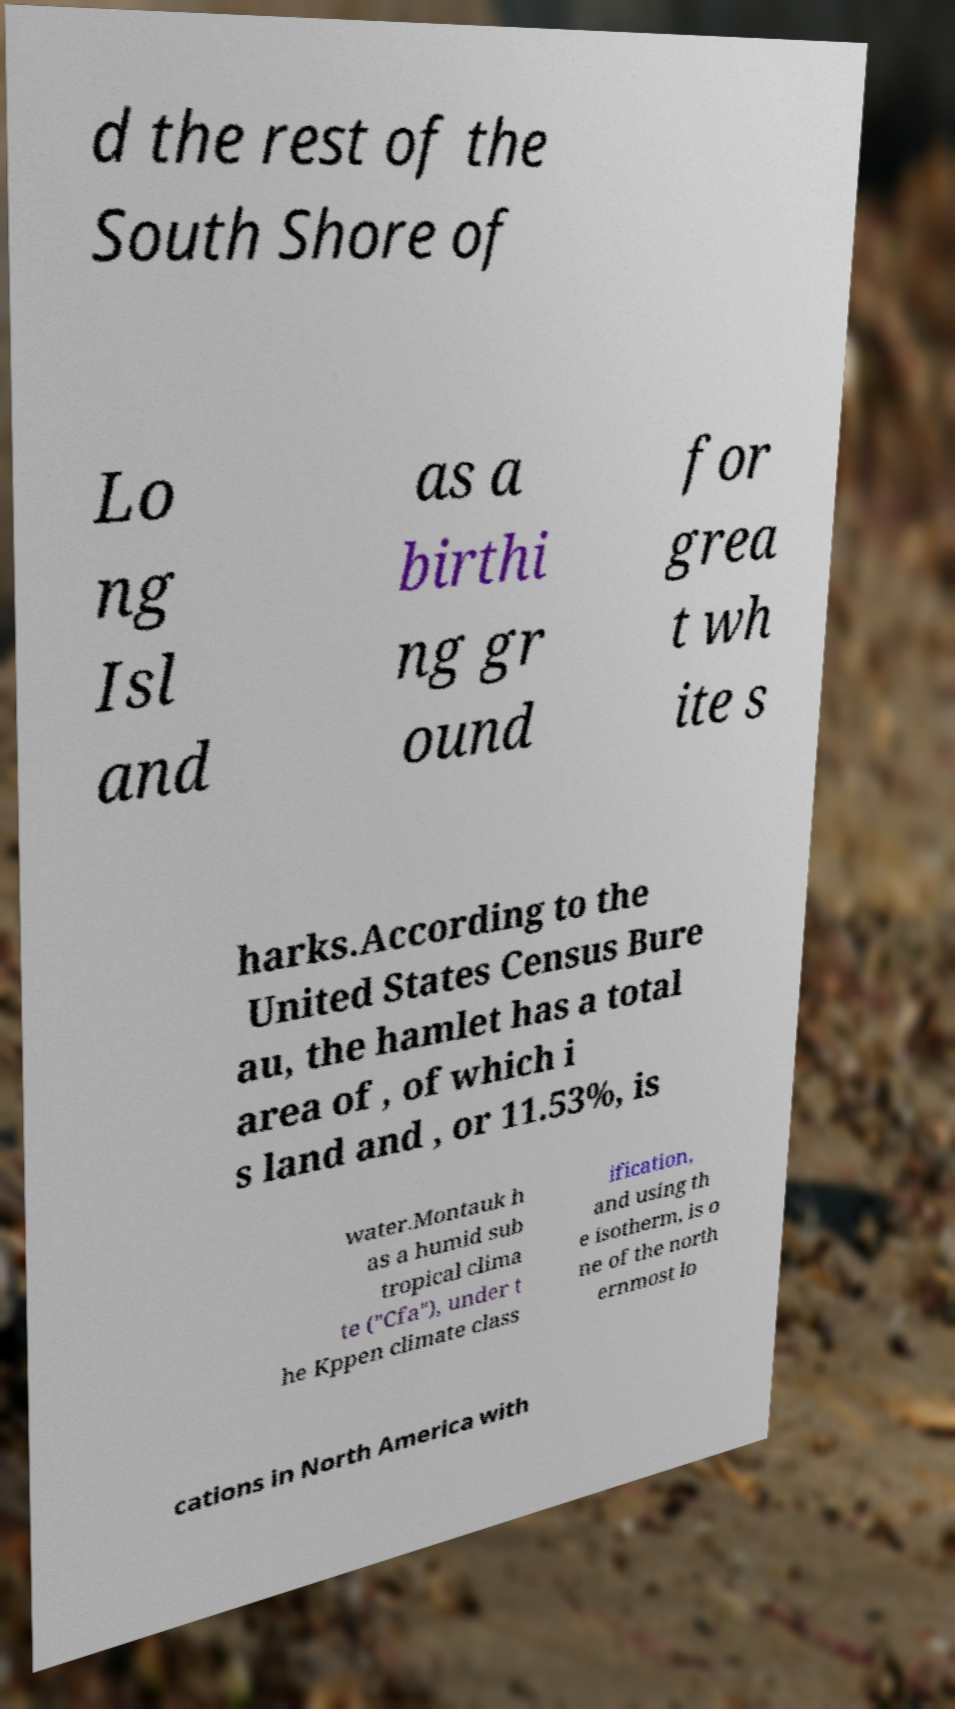For documentation purposes, I need the text within this image transcribed. Could you provide that? d the rest of the South Shore of Lo ng Isl and as a birthi ng gr ound for grea t wh ite s harks.According to the United States Census Bure au, the hamlet has a total area of , of which i s land and , or 11.53%, is water.Montauk h as a humid sub tropical clima te ("Cfa"), under t he Kppen climate class ification, and using th e isotherm, is o ne of the north ernmost lo cations in North America with 